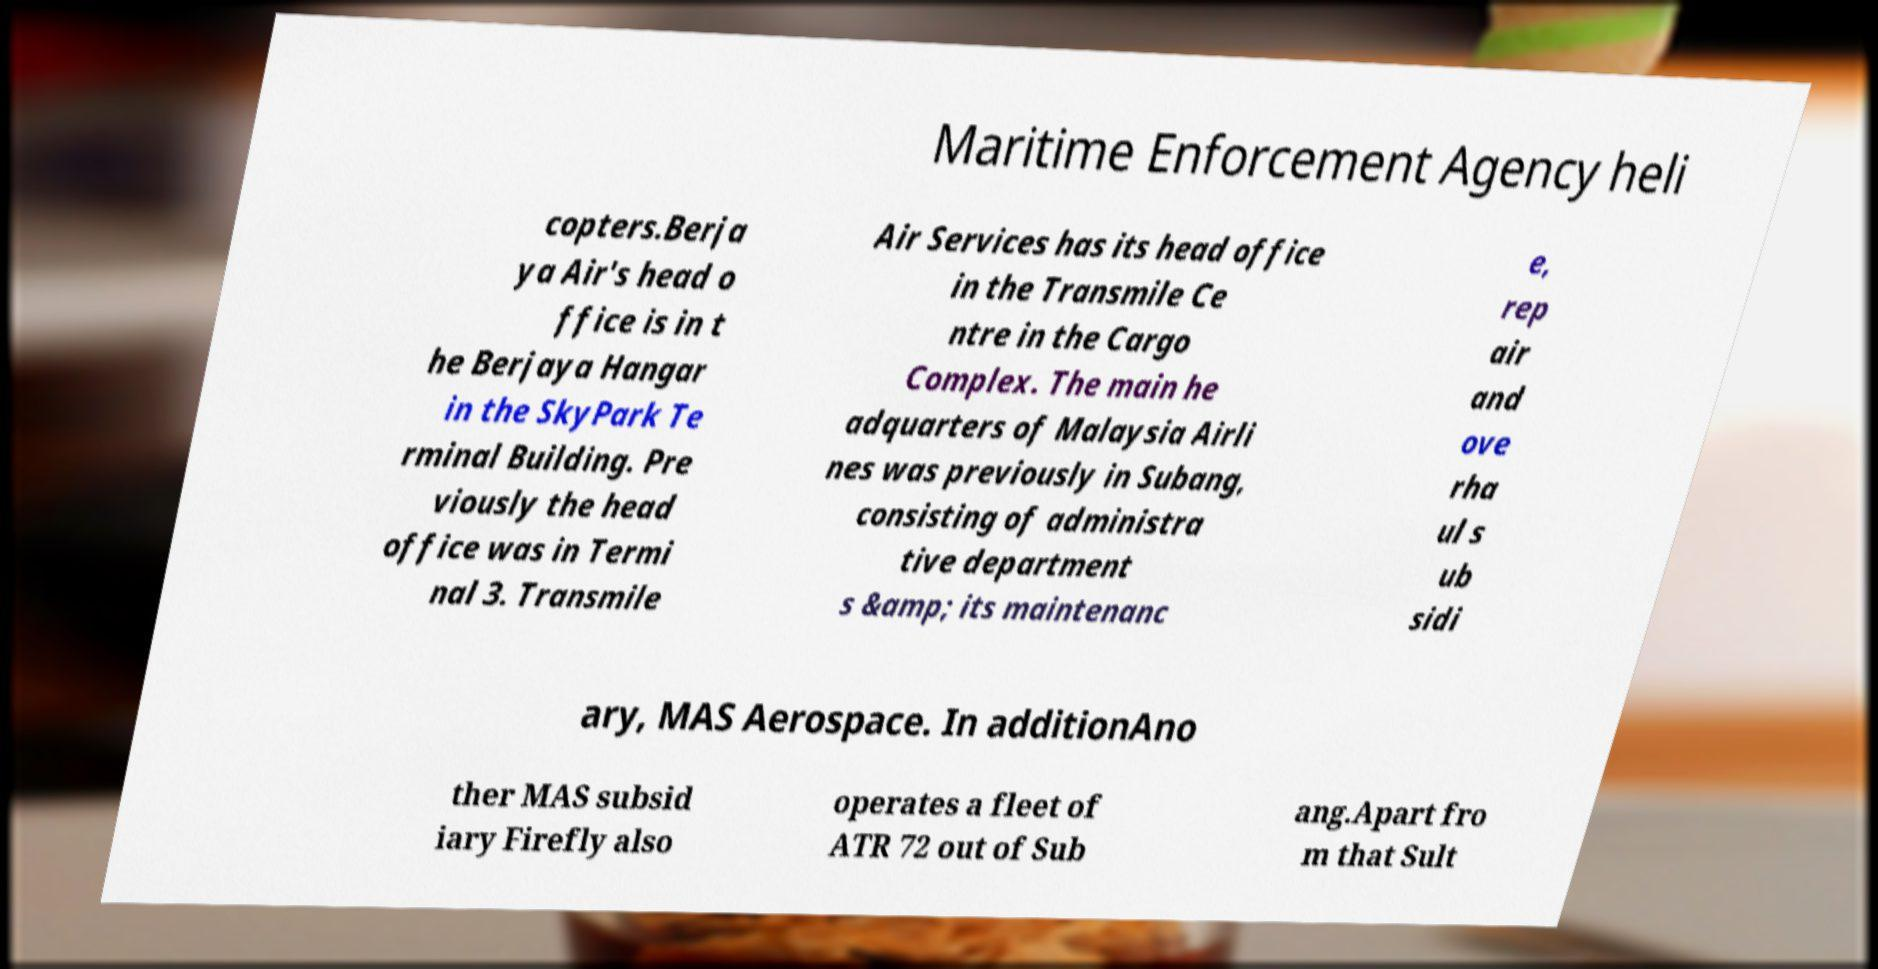For documentation purposes, I need the text within this image transcribed. Could you provide that? Maritime Enforcement Agency heli copters.Berja ya Air's head o ffice is in t he Berjaya Hangar in the SkyPark Te rminal Building. Pre viously the head office was in Termi nal 3. Transmile Air Services has its head office in the Transmile Ce ntre in the Cargo Complex. The main he adquarters of Malaysia Airli nes was previously in Subang, consisting of administra tive department s &amp; its maintenanc e, rep air and ove rha ul s ub sidi ary, MAS Aerospace. In additionAno ther MAS subsid iary Firefly also operates a fleet of ATR 72 out of Sub ang.Apart fro m that Sult 